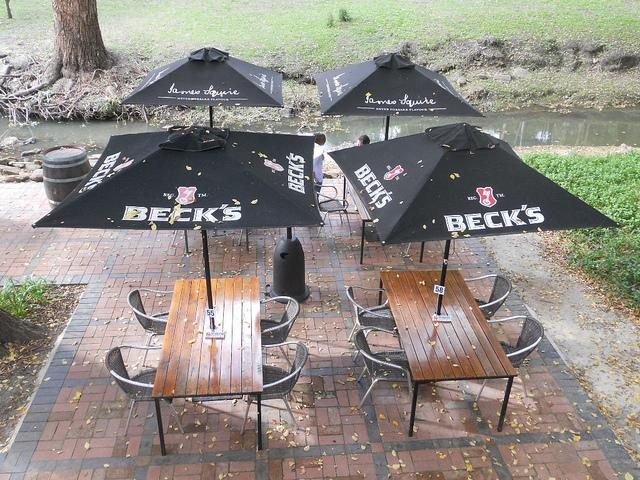What do the umbrellas offer those who sit here? Please explain your reasoning. shade. Traditionally umbrella's offer shade and means to be dry when raining. 